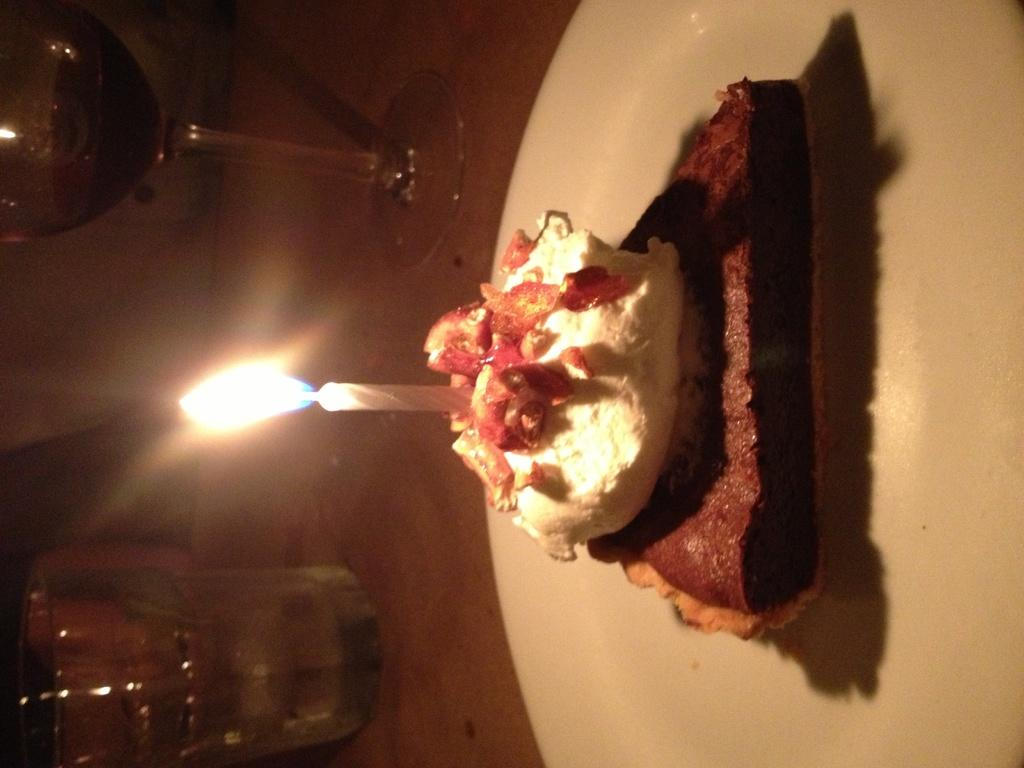What is the main object on the plate in the image? There is a cake with a candle in the image. What is the state of the candle in the image? The candle has a flame. Where is the cake placed in the image? The cake is placed on a plate. What other types of glasses are present in the image besides the wine glass? There is a glass in the image. Where are the wine glass and the glass located in the image? The wine glass and the glass are placed on a table. Where is the plate with the cake located in the image? The plate with the cake is also placed on the table. What is the design of the town visible in the image? There is no town visible in the image; it features a cake with a candle, a wine glass, a glass, and a plate. How can the wine glass be used to measure the volume of liquid in the image? The image does not show the wine glass being used to measure anything; it is simply present on the table. 